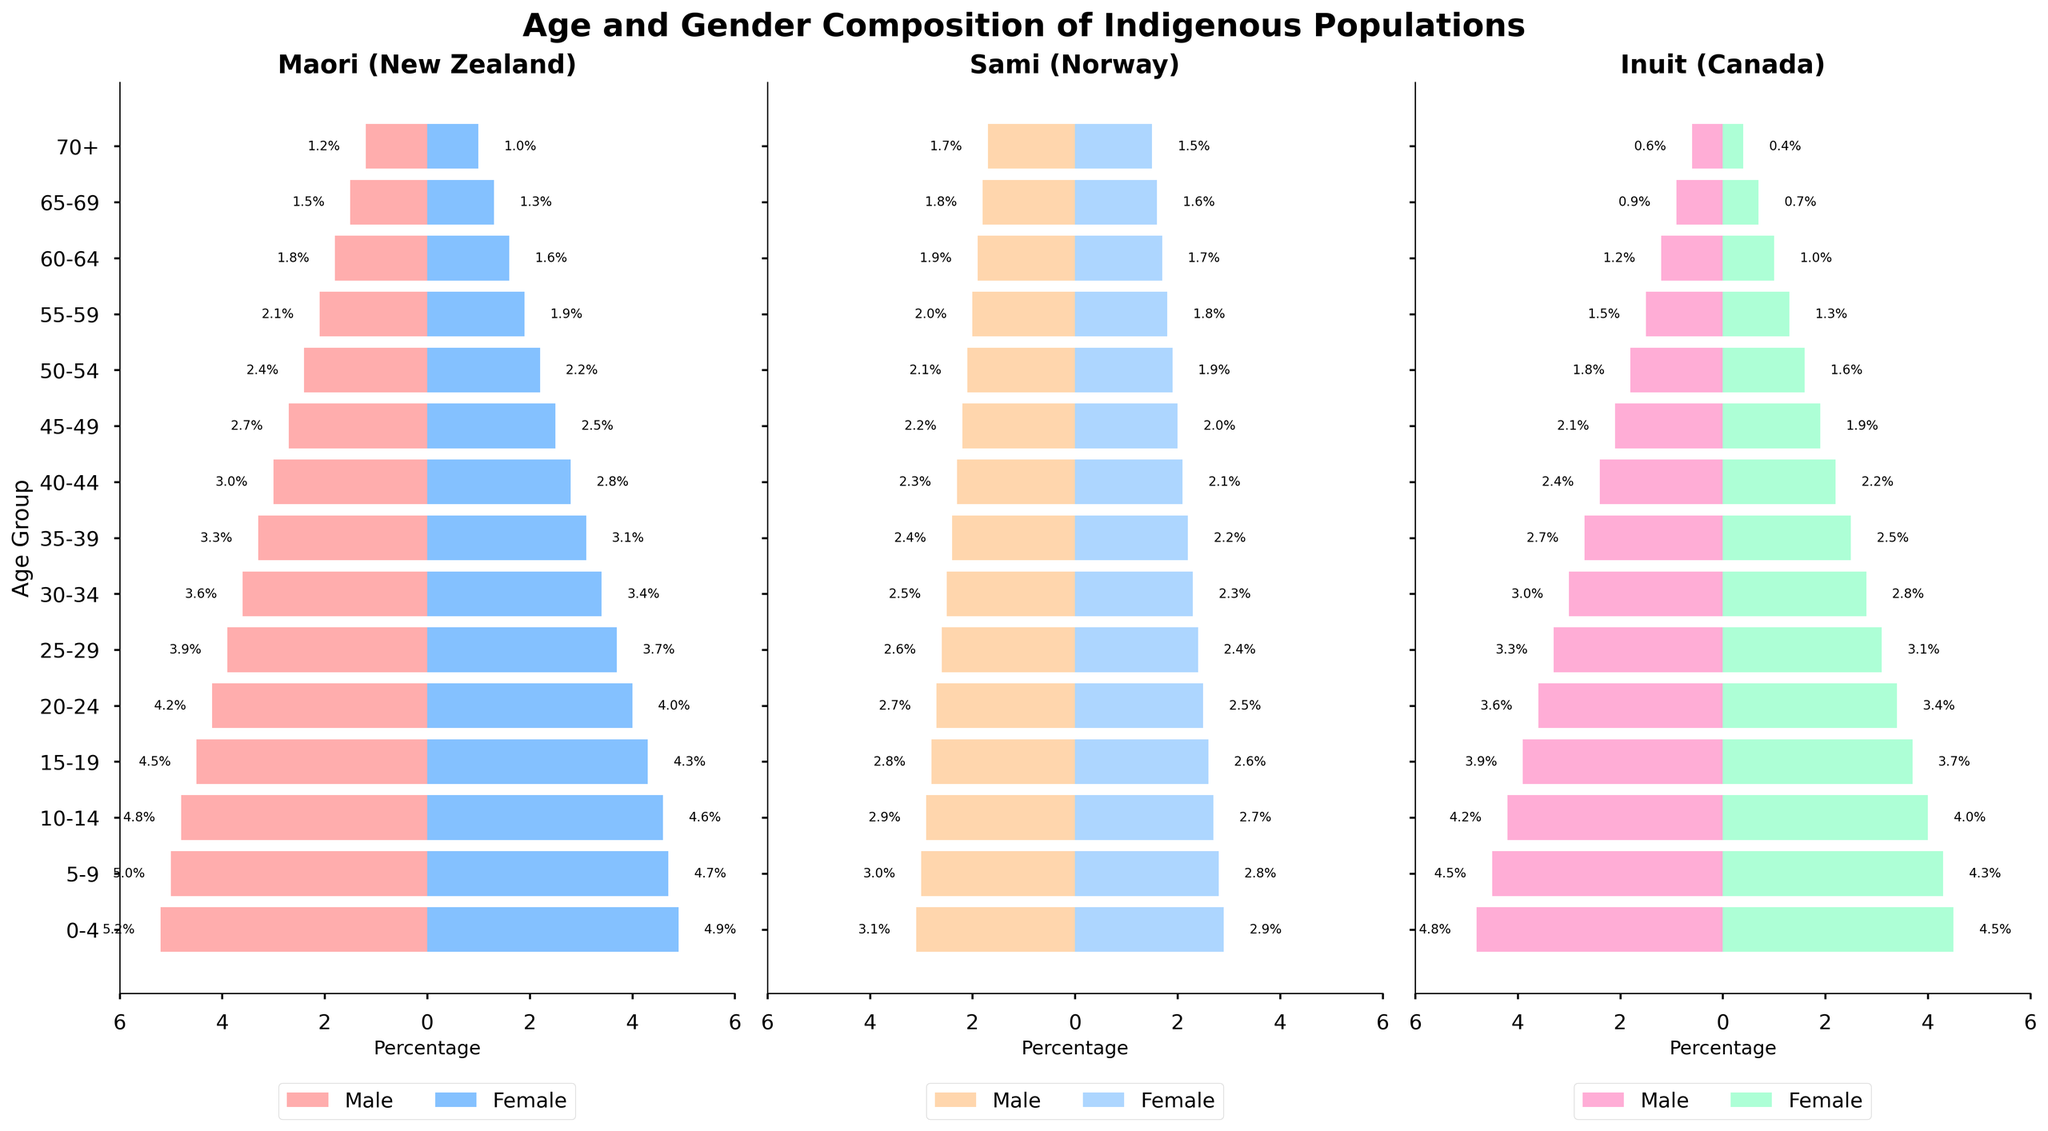What is the title of the figure? The title can be found at the top of the figure. It provides a clear overview of what the data represents.
Answer: Age and Gender Composition of Indigenous Populations What are the colors used to represent males and females in the Maori population on the left panel? The colors are visible in the bars representing males and females in the leftmost panel of the figure, titled 'Maori (New Zealand)'.
Answer: Red for males and blue for females How many age groups are depicted in the figure? Counting the number of different age ranges on the y-axis labels gives us the number of age groups.
Answer: 15 Which population has the highest percentage of males in the 0-4 age group? Compare the values of the male population in the 0-4 age group across the three pyramids.
Answer: Maori in New Zealand (5.2%) In the Sami population, which age group has the largest percentage of females? Look at the bars representing females in the Sami population pyramid and identify the group with the largest bar length.
Answer: 0-4 age group (2.9%) What is the percentage difference between male and female Inuit populations aged 10-14? Find the values for males and females aged 10-14 in the Inuit population pyramid, and compute the difference.
Answer: 4.2% - 4.0% = 0.2% In which population and age group is the gender difference most noticeable? Compare the lengths of the male and female bars in each age group across all three populations to find the largest difference.
Answer: Maori in New Zealand, 0-4 age group What percentage of the Maori population in New Zealand is aged 25-29? Add up the percentages of males and females aged 25-29 in the Maori population.
Answer: 3.9% + 3.7% = 7.6% Identify the age group where the male Inuit population shows a sharp decrease compared to the previous age group. Examine the male Inuit population bars and notice the first age group where a significant decline occurs.
Answer: 60-64 age group (from 1.5% to 1.2%) Compare the percentage of females aged 55-59 across all three populations. Which population has the highest percentage in this age group? Find the values for females aged 55-59 in each population pyramid and determine which is the highest.
Answer: Sami in Norway (1.8%) 